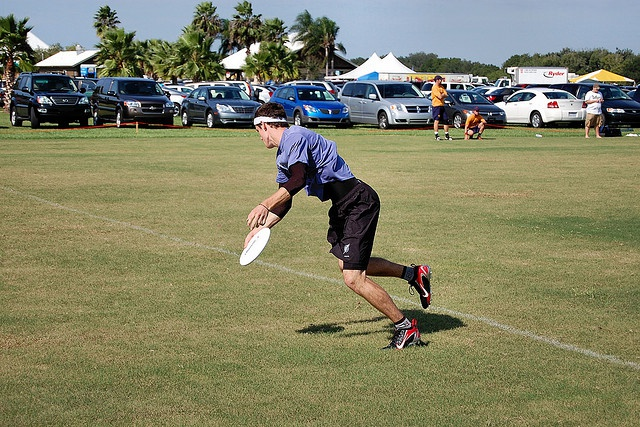Describe the objects in this image and their specific colors. I can see people in darkgray, black, tan, and maroon tones, truck in darkgray, black, gray, and blue tones, car in darkgray, white, black, and gray tones, car in darkgray, black, gray, and lightgray tones, and truck in darkgray, black, gray, and navy tones in this image. 